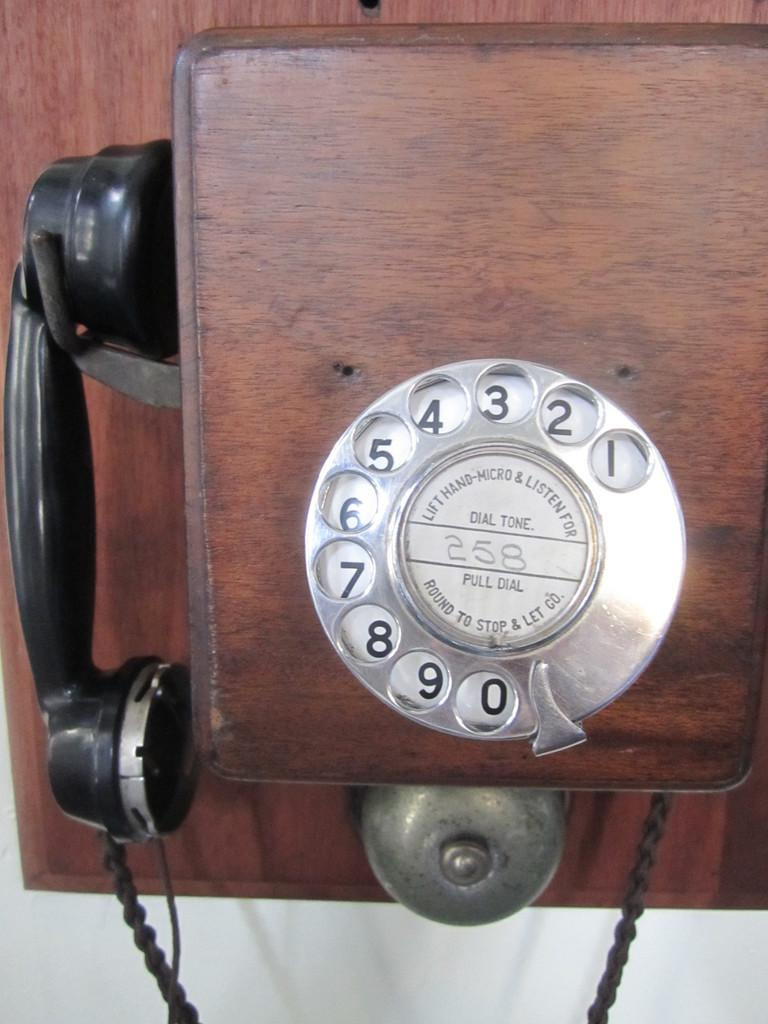<image>
Offer a succinct explanation of the picture presented. A rotary phone has instructions that read "lift hand-micro & listen for dial tone." 